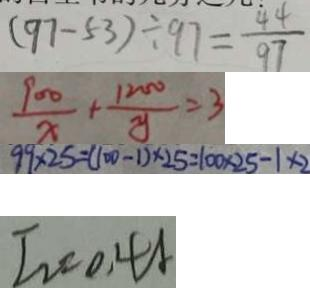<formula> <loc_0><loc_0><loc_500><loc_500>( 9 7 - 5 3 ) \div 9 7 = \frac { 4 4 } { 9 7 } 
 \frac { 9 0 0 } { x } + \frac { 1 2 0 0 } { x } = 3 
 9 9 \times 2 5 = ( 1 0 0 - 1 ) \times 2 5 = 1 0 0 \times 2 5 - 1 \times 2 
 I _ { 2 } = 0 . 4 A</formula> 